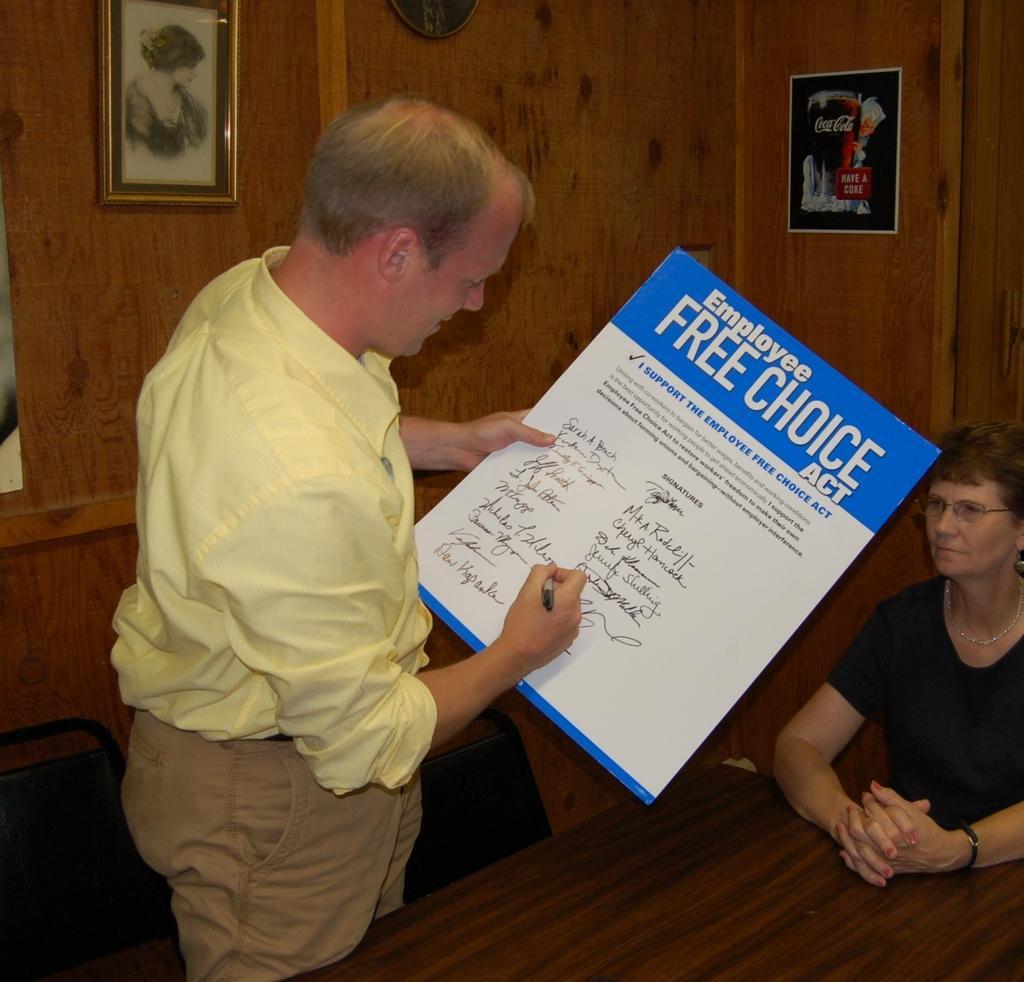Could you give a brief overview of what you see in this image? There is a man holding poster and a pen in his hands, there is a lady sitting on the right side and a table at the bottom side. There are frames in the background area. 